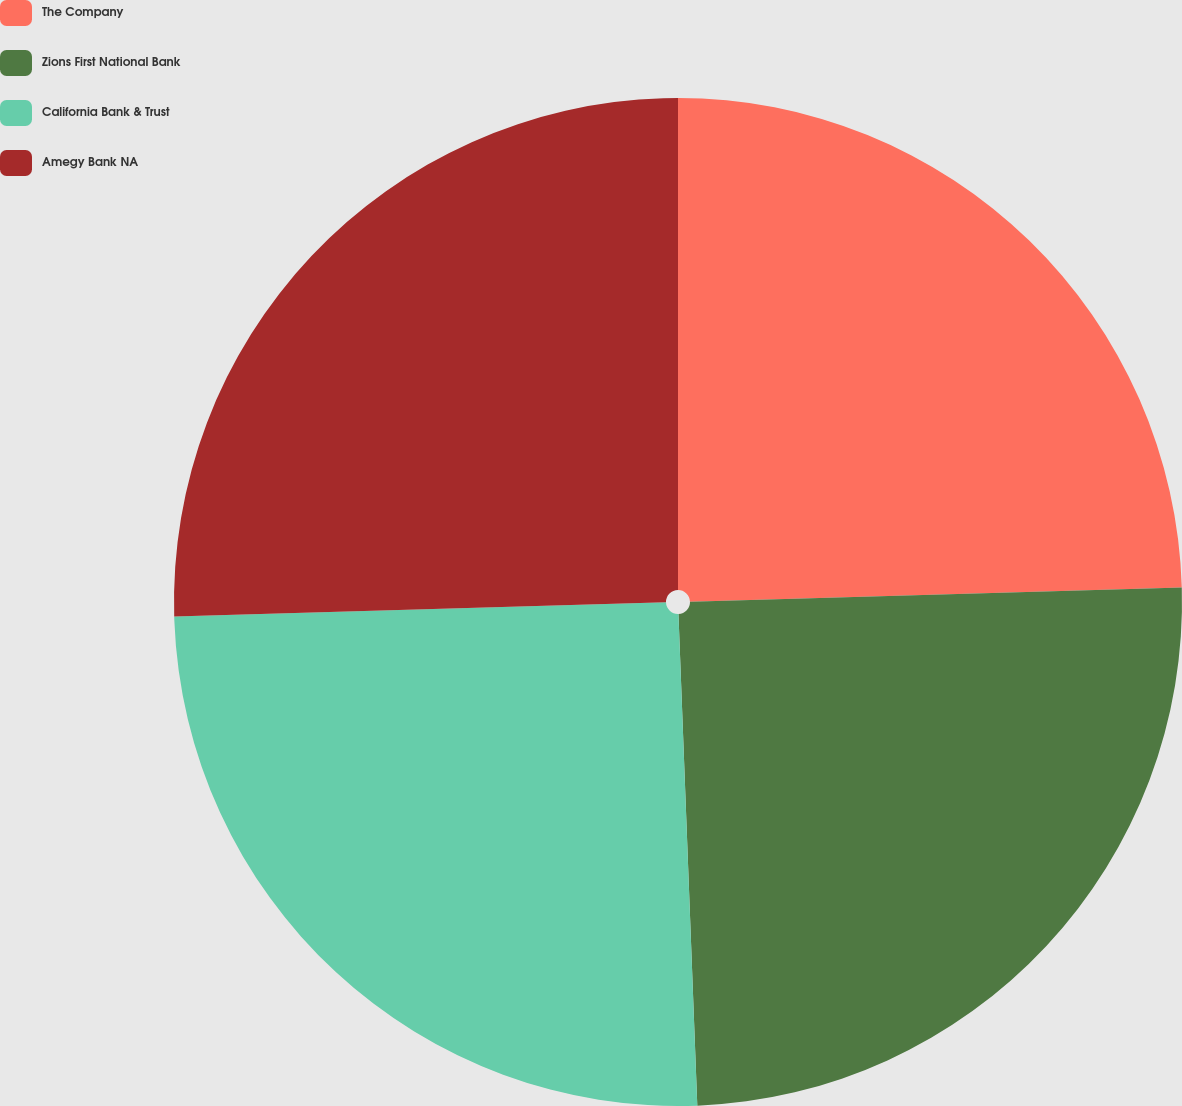Convert chart to OTSL. <chart><loc_0><loc_0><loc_500><loc_500><pie_chart><fcel>The Company<fcel>Zions First National Bank<fcel>California Bank & Trust<fcel>Amegy Bank NA<nl><fcel>24.54%<fcel>24.85%<fcel>25.15%<fcel>25.46%<nl></chart> 